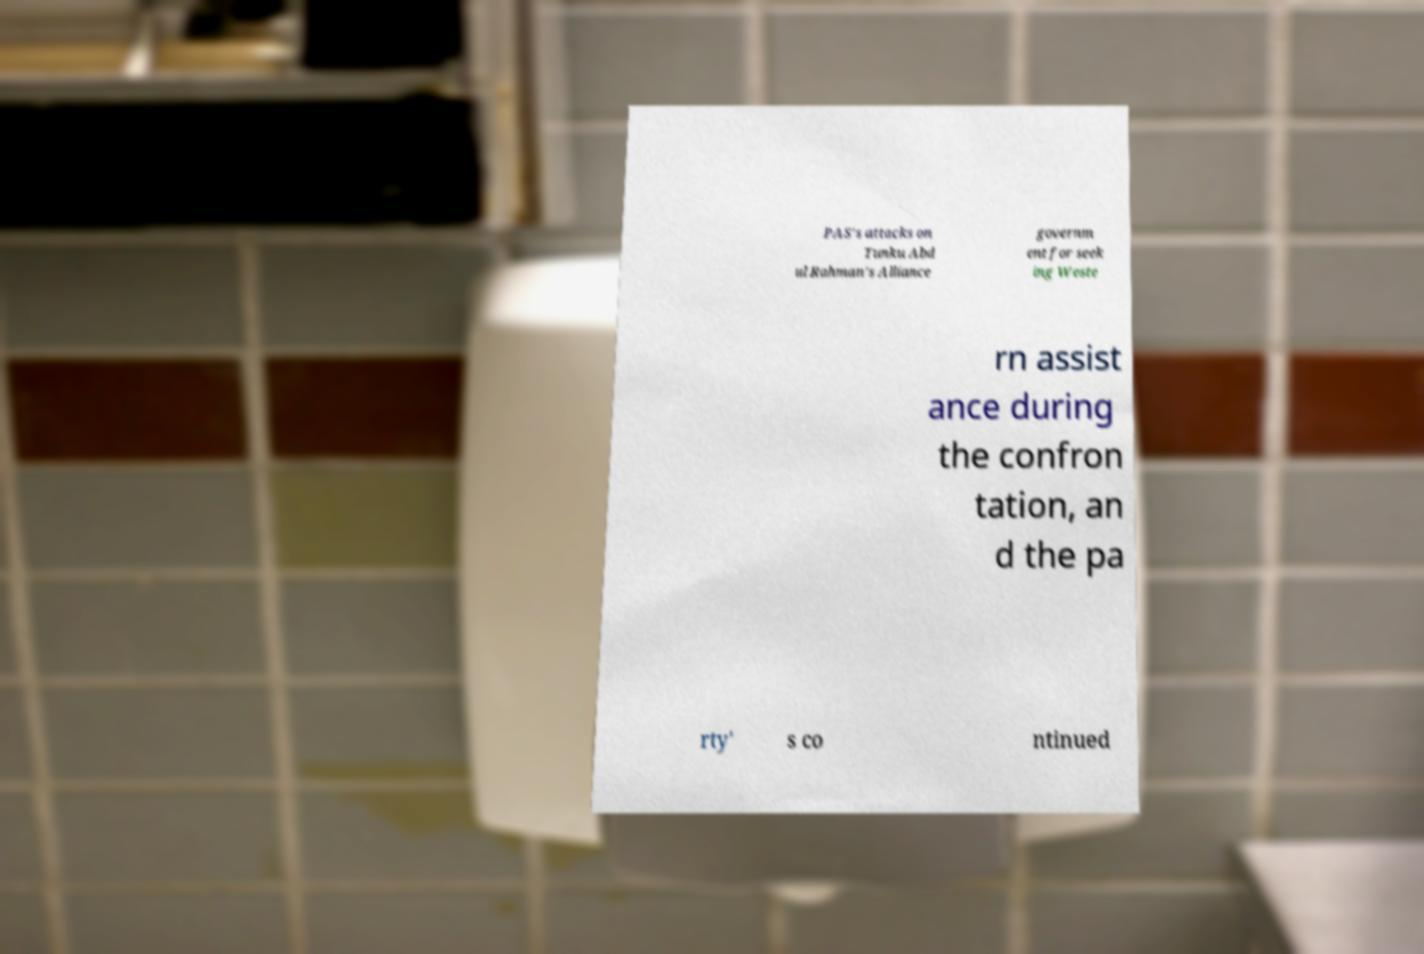Please identify and transcribe the text found in this image. PAS's attacks on Tunku Abd ul Rahman's Alliance governm ent for seek ing Weste rn assist ance during the confron tation, an d the pa rty' s co ntinued 